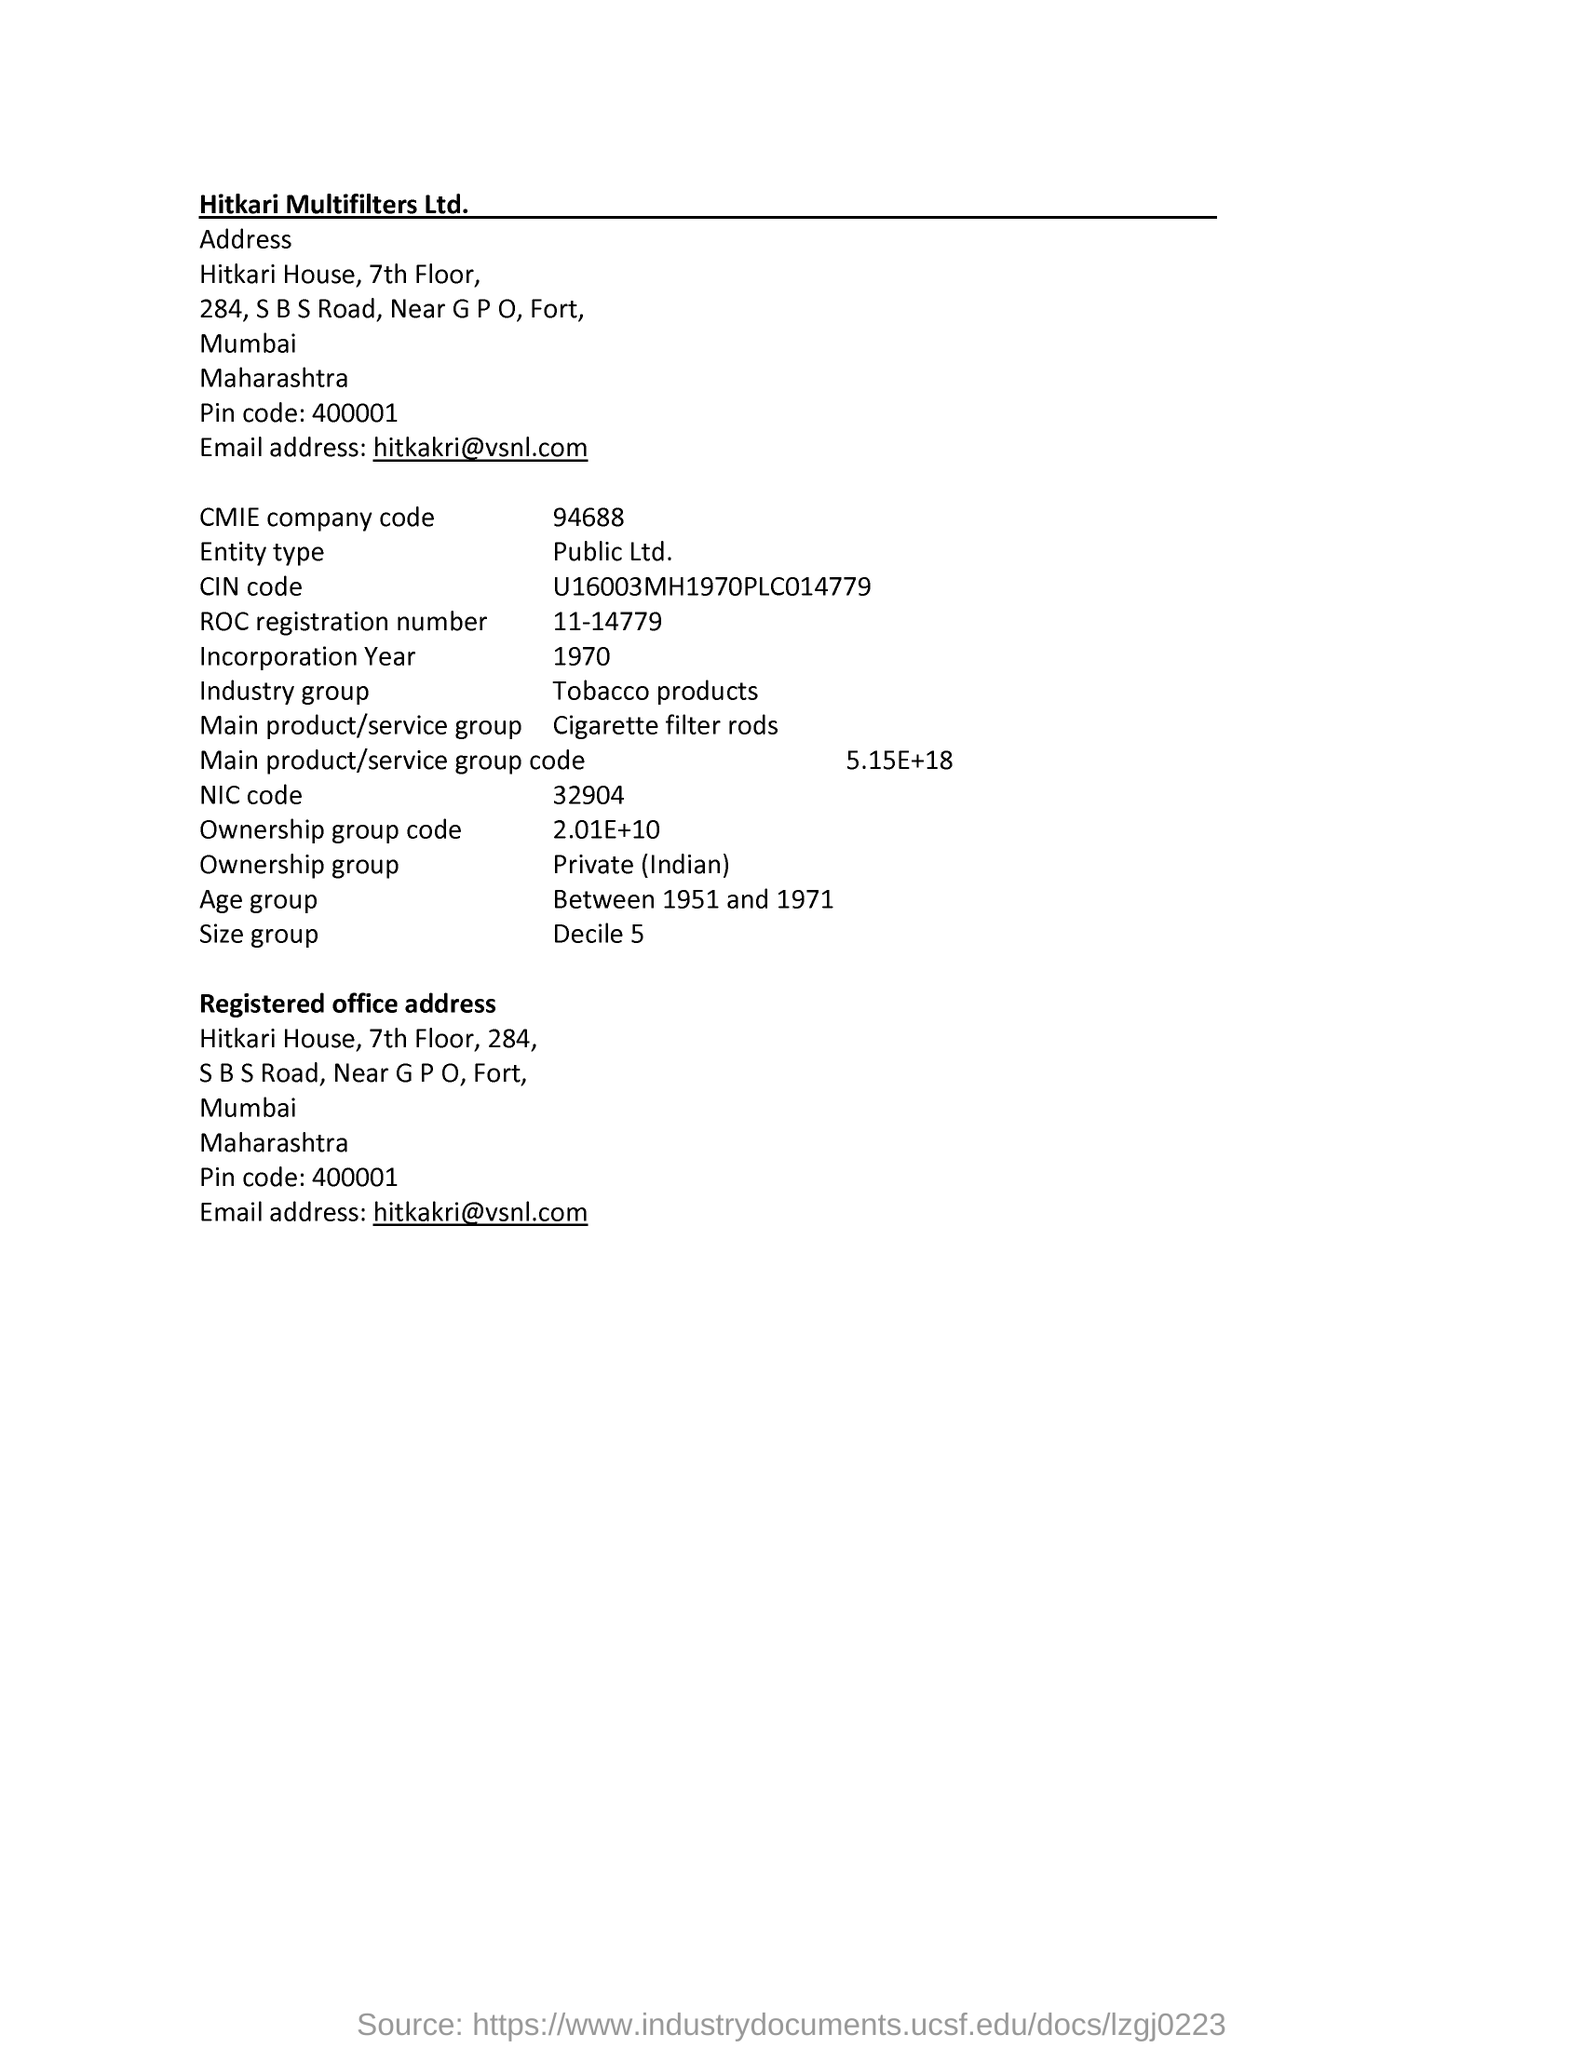What is the email address of Hitkari Multifilters Ltd.?
Provide a short and direct response. Hitkakri@vsnl.com. What is the CMIE company code?
Keep it short and to the point. 94688. What is the Entity type?
Provide a short and direct response. Public Ltd. What is the ROC registration number?
Provide a short and direct response. 11-14779. What is the NIC code?
Provide a short and direct response. 32904. What is the Ownership group code?
Give a very brief answer. 2.01E+10. 